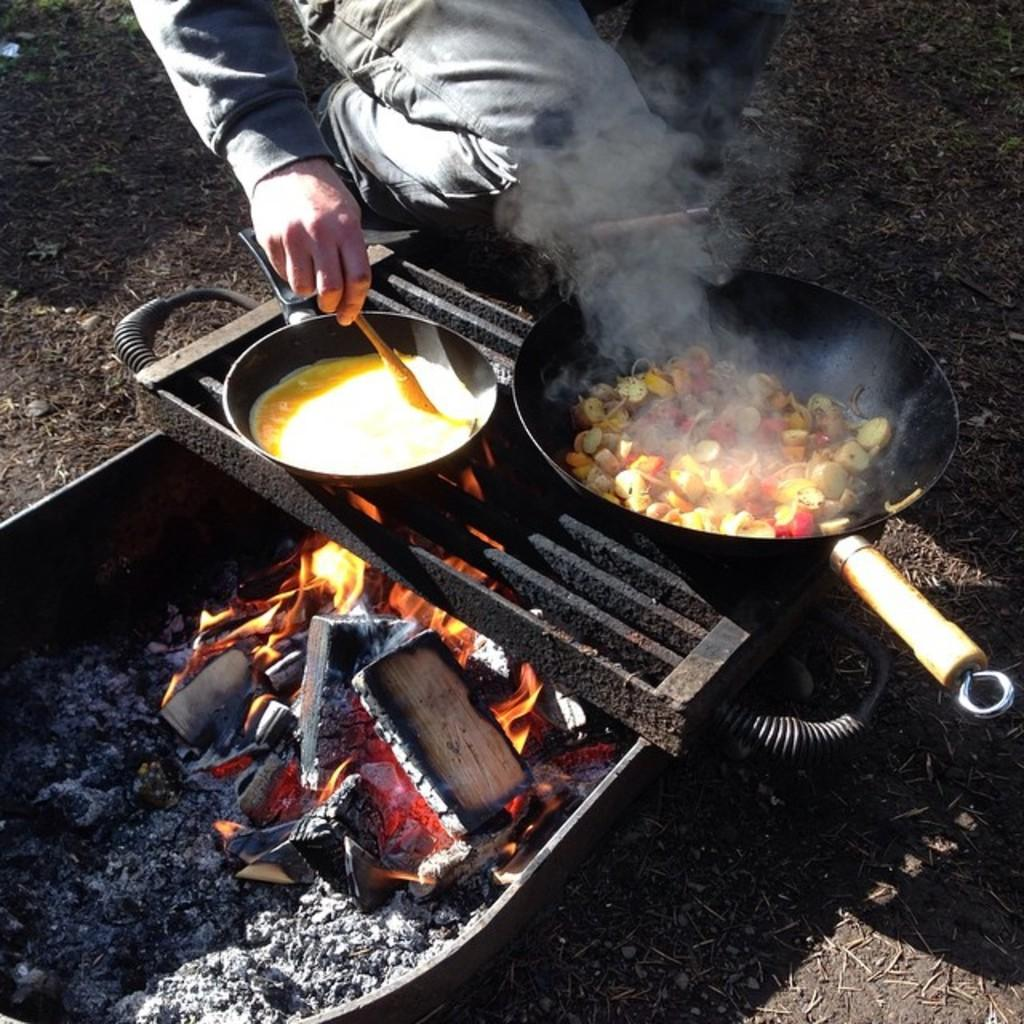Who is present in the image? There is a man in the image. Where is the man located in the image? The man is at the top of the image. What is the man wearing? The man is wearing a jacket and trousers. What is the man doing in the image? The man is cooking. What cooking equipment is visible in the image? There is a grill and a furnace in the image. What is being cooked on the grill and furnace? There are bowls on the grill and furnace, and food items are on the bowls. How many horses are present in the image? There are no horses present in the image. Is the boy in the image enjoying the food being cooked? There is no boy present in the image. 